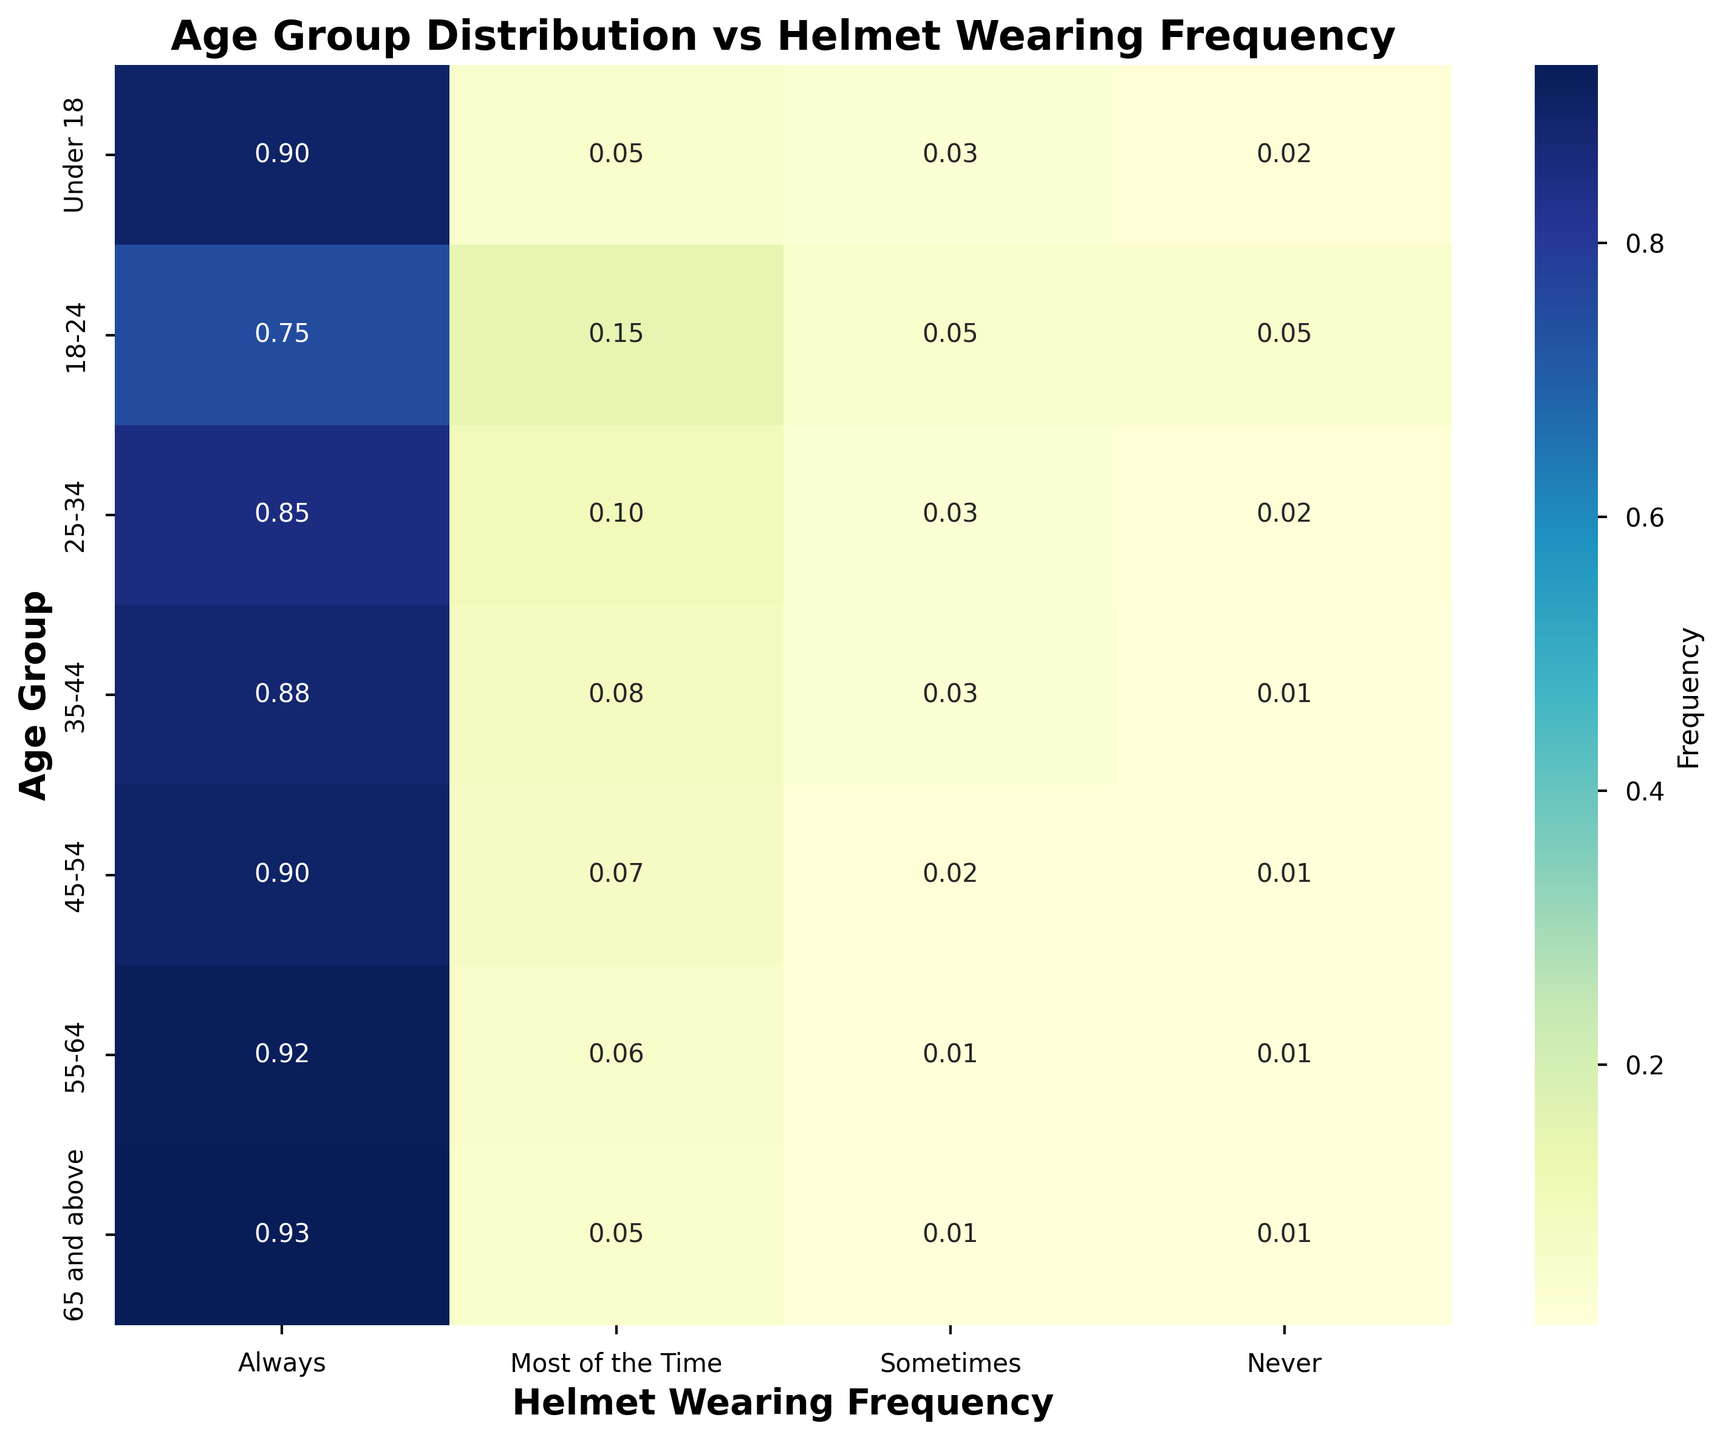What age group has the highest frequency of always wearing a helmet? To find the age group with the highest frequency of always wearing a helmet, look at the row with the highest value in the "Always" column. The highest value in the "Always" column is 0.93, which corresponds to the '65 and above' age group.
Answer: 65 and above Which age groups have the lowest frequency of never wearing a helmet? To find the age groups with the lowest frequency of never wearing a helmet, look at the "Never" column and identify the rows with the lowest values. The lowest value in the "Never" column is 0.01, which applies to the '35-44', '45-54', '55-64', and '65 and above' age groups.
Answer: 35-44, 45-54, 55-64, 65 and above What is the difference in the frequency of always wearing a helmet between the '18-24' and '25-34' age groups? To calculate the difference, subtract the value in the "Always" column for '18-24' from the value for '25-34'. The frequency for '18-24' is 0.75, and for '25-34' it is 0.85. Therefore, 0.85 - 0.75 = 0.10.
Answer: 0.10 How does the frequency of always wearing a helmet change across age groups? To observe the change, look at the values in the "Always" column from top to bottom. It increases from 0.9 for 'Under 18' to 0.93 for '65 and above', showing a general upward trend with age.
Answer: Increases with age Which age group has the most even distribution of helmet-wearing frequencies? The age group with the most even distribution will have values in the different columns that are most similar. The '18-24' age group shows a more balanced distribution with values 0.75, 0.15, 0.05, and 0.05.
Answer: 18-24 What is the average frequency of always wearing a helmet across all age groups? To find the average, sum all the values in the "Always" column and divide by the number of age groups. (0.9 + 0.75 + 0.85 + 0.88 + 0.90 + 0.92 + 0.93) / 7 = 6.13 / 7 = 0.88.
Answer: 0.88 For which age group is the frequency of "most of the time" highest? Look at the "Most of the Time" column and identify the highest value. The highest value is 0.15, corresponding to the '18-24' age group.
Answer: 18-24 